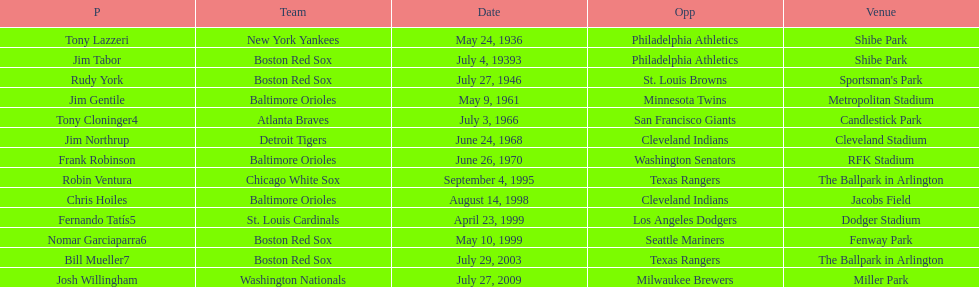Who is the first major league hitter to hit two grand slams in one game? Tony Lazzeri. 